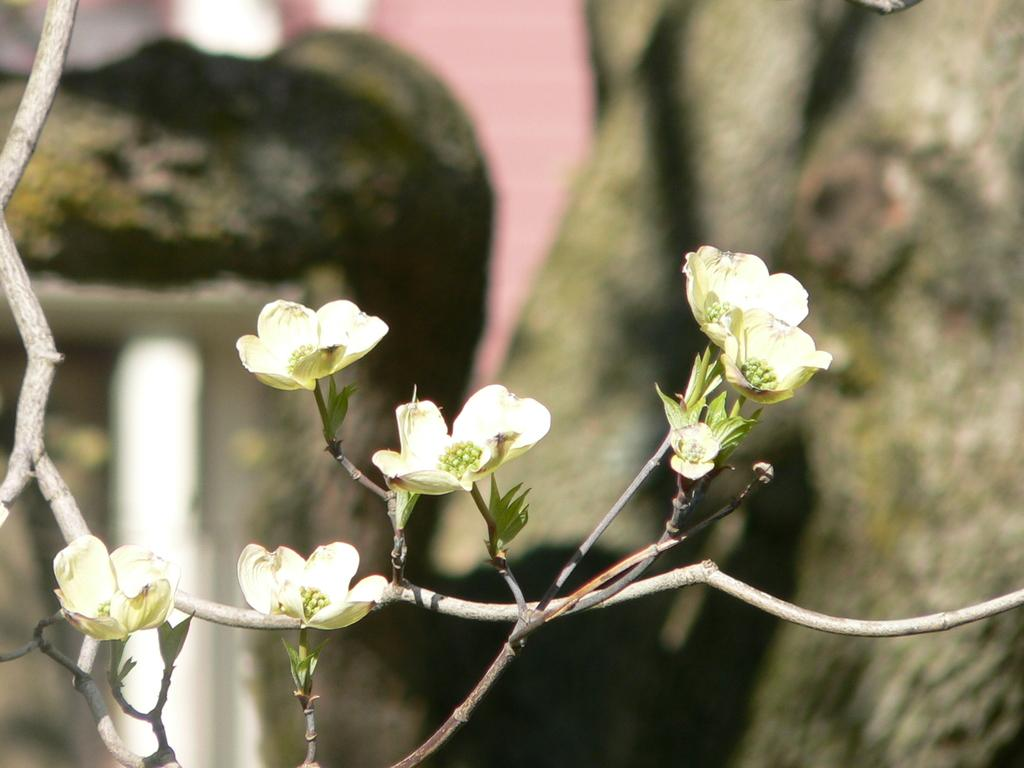What type of plants can be seen in the image? There are flowers in the image. What material is present in the image? There is wood in the image. Can you describe the background of the image? The background of the image is blurred. What type of cloth is being used to stop the hot object in the image? There is no hot object or cloth present in the image. 